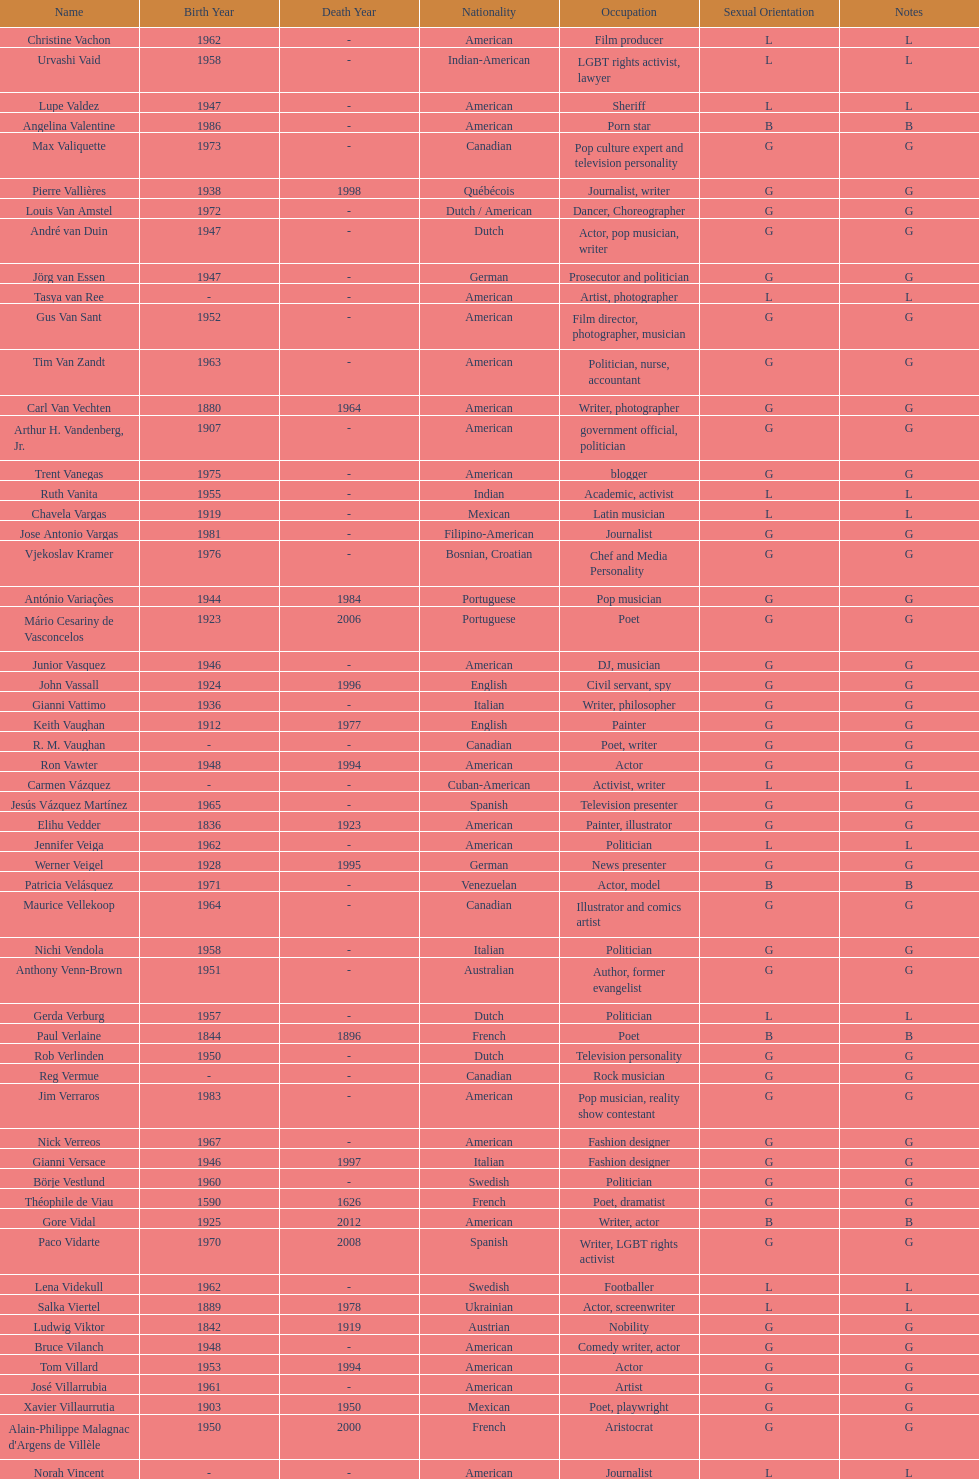What is the number of individuals in this group who were indian? 1. 